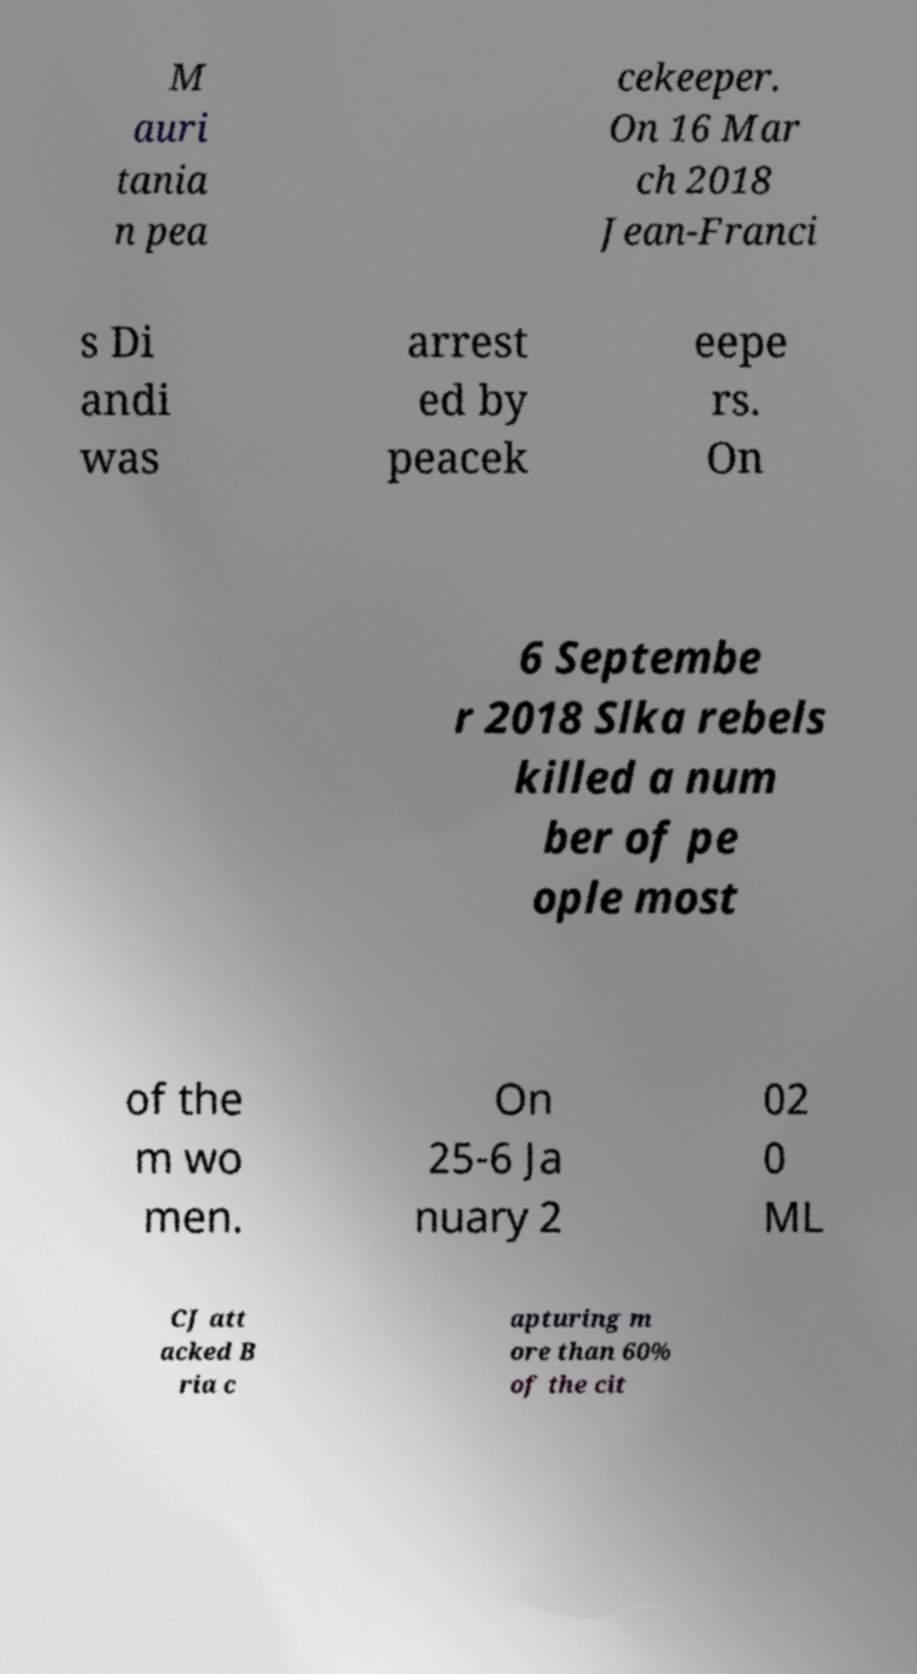Please read and relay the text visible in this image. What does it say? M auri tania n pea cekeeper. On 16 Mar ch 2018 Jean-Franci s Di andi was arrest ed by peacek eepe rs. On 6 Septembe r 2018 Slka rebels killed a num ber of pe ople most of the m wo men. On 25-6 Ja nuary 2 02 0 ML CJ att acked B ria c apturing m ore than 60% of the cit 